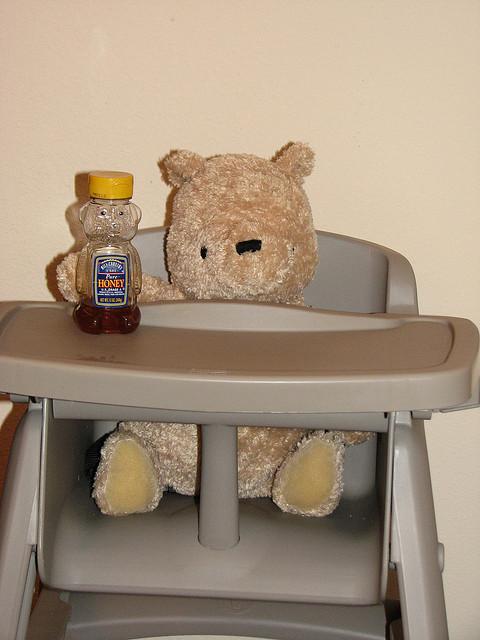What is the name of this famous bear?
Quick response, please. Teddy. What are the contents of this bottle?
Quick response, please. Honey. Why is there a honey bottle near the stuffed bear?
Keep it brief. Yes. 